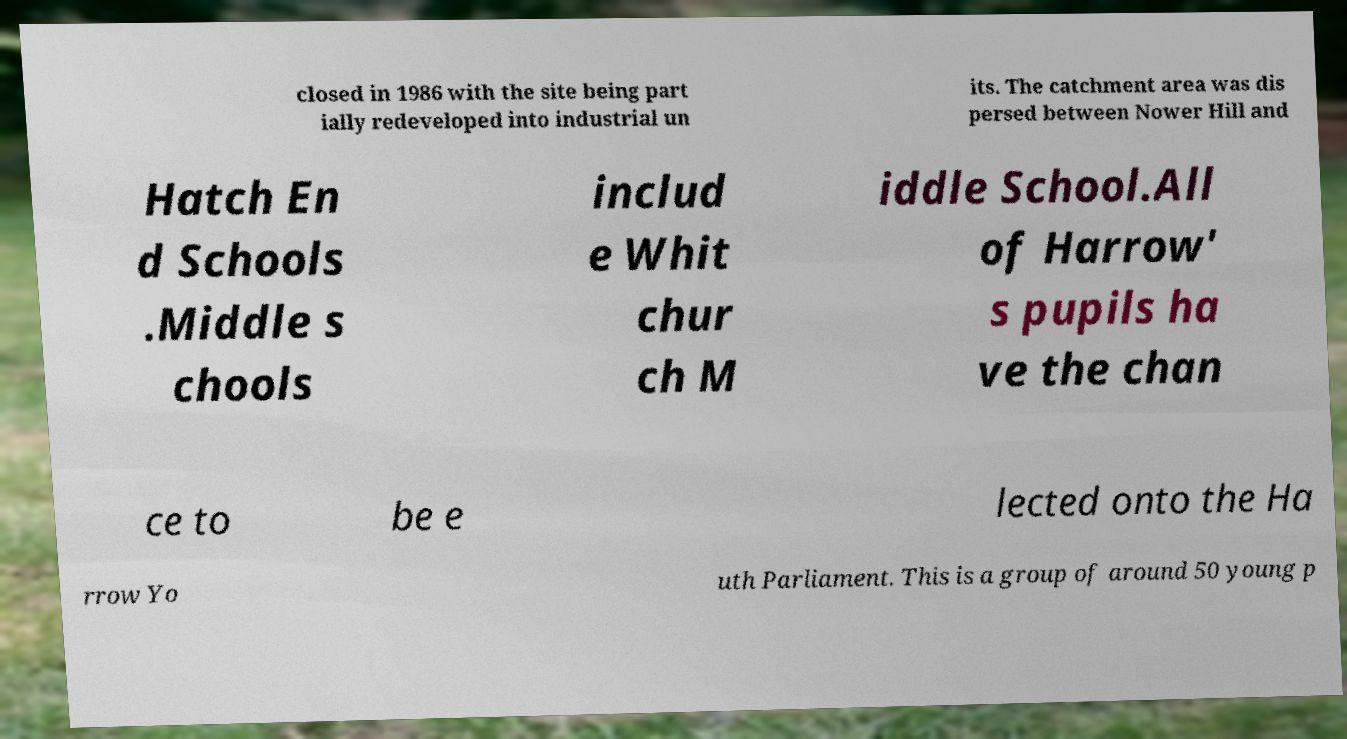Could you extract and type out the text from this image? closed in 1986 with the site being part ially redeveloped into industrial un its. The catchment area was dis persed between Nower Hill and Hatch En d Schools .Middle s chools includ e Whit chur ch M iddle School.All of Harrow' s pupils ha ve the chan ce to be e lected onto the Ha rrow Yo uth Parliament. This is a group of around 50 young p 